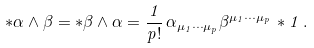<formula> <loc_0><loc_0><loc_500><loc_500>* \alpha \wedge \beta = * \beta \wedge \alpha = \frac { 1 } { p ! } \, \alpha _ { \mu _ { 1 } \cdots \mu _ { p } } \beta ^ { \mu _ { 1 } \cdots \mu _ { p } } \, * 1 \, .</formula> 